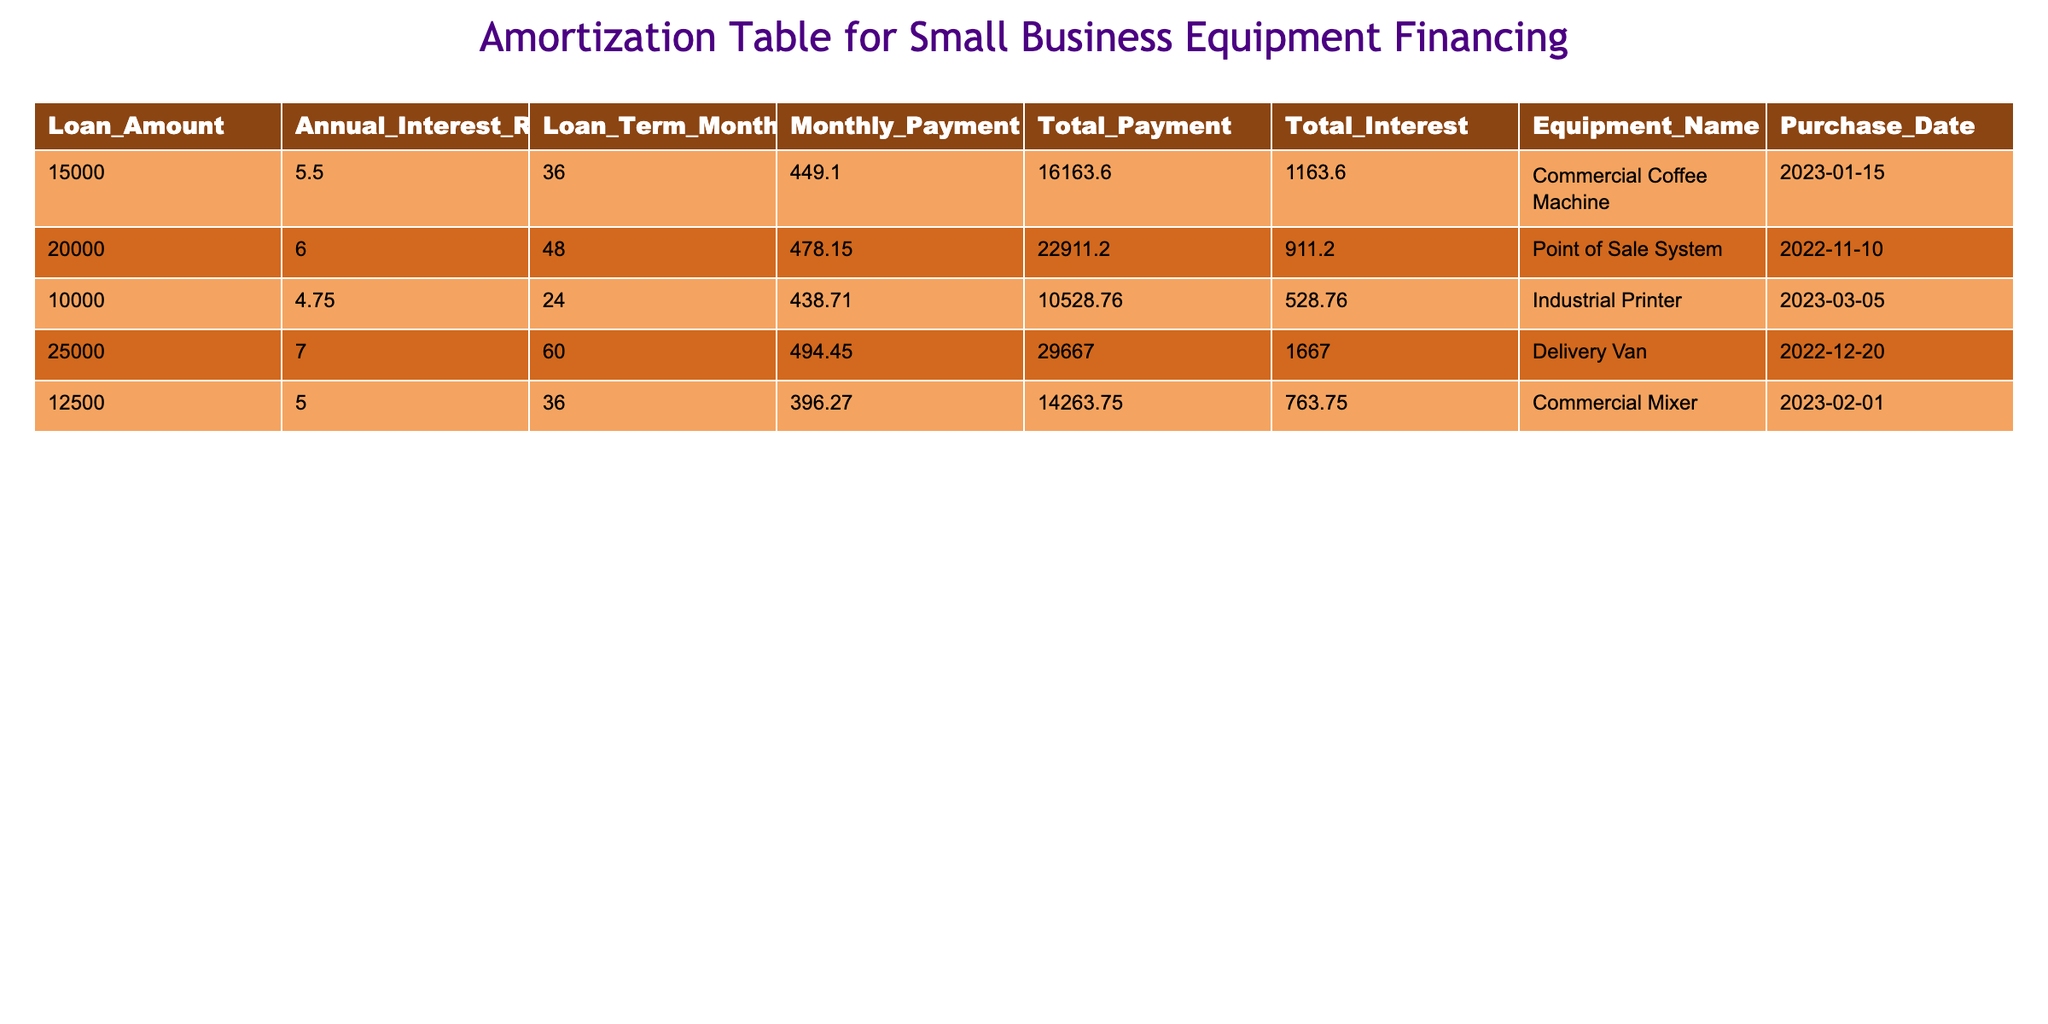What is the total amount of interest paid over all loans? To find the total interest, we need to add the interest amounts from each loan in the table: 1163.60 + 911.20 + 528.76 + 1667.00 + 763.75 = 5034.31
Answer: 5034.31 Which equipment has the highest monthly payment? By comparing the monthly payments listed for each piece of equipment, the Delivery Van has a monthly payment of 494.45, which is the highest among all listed payments.
Answer: Delivery Van Is the Total Payment for the Industrial Printer less than 10,000? The Total Payment for the Industrial Printer is 10528.76, which is greater than 10,000. Hence, the statement is false.
Answer: No What is the average loan amount for all equipment listed? To calculate the average loan amount, we sum all loan amounts (15000 + 20000 + 10000 + 25000 + 12500 = 82500), then divide by the number of loans (5). Thus, 82500 / 5 = 16500.
Answer: 16500 How many loans have an Annual Interest Rate greater than 5.5%? In the table, the following loans have an interest rate greater than 5.5%: Point of Sale System (6.0) and Delivery Van (7.0), totaling 2 loans.
Answer: 2 